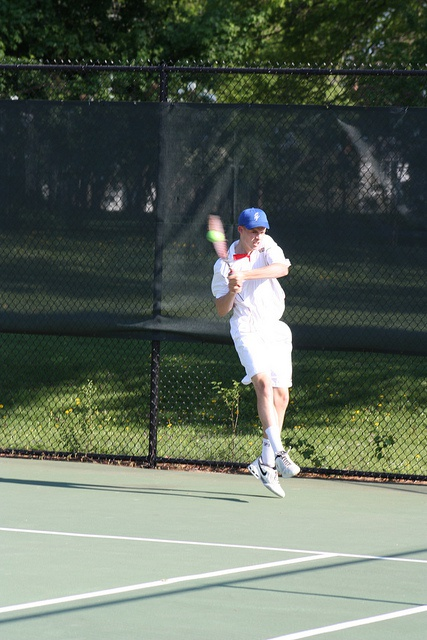Describe the objects in this image and their specific colors. I can see people in black, white, lavender, and gray tones, tennis racket in black, lightpink, darkgray, pink, and gray tones, and sports ball in black, beige, khaki, green, and lightgreen tones in this image. 